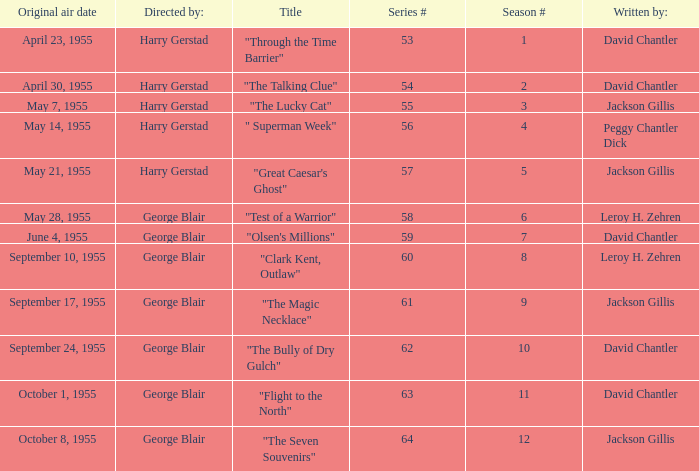What is the lowest number of series? 53.0. 